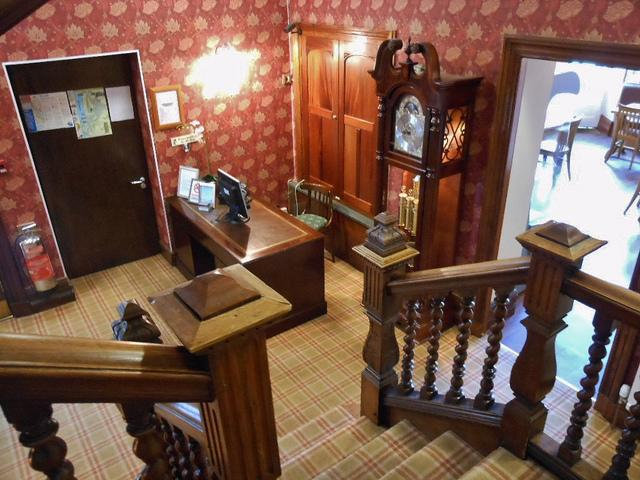What is attached to the brown door? posters 